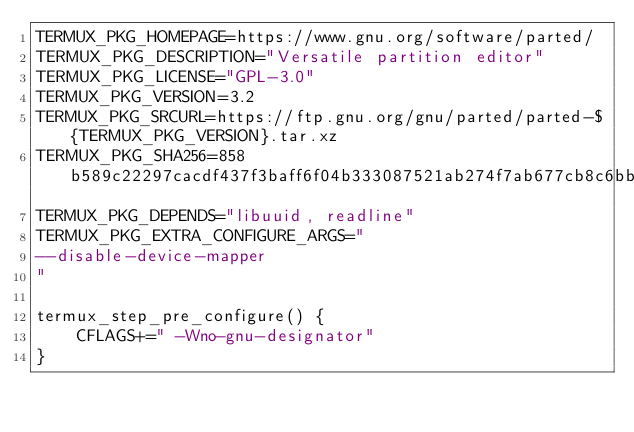<code> <loc_0><loc_0><loc_500><loc_500><_Bash_>TERMUX_PKG_HOMEPAGE=https://www.gnu.org/software/parted/
TERMUX_PKG_DESCRIPTION="Versatile partition editor"
TERMUX_PKG_LICENSE="GPL-3.0"
TERMUX_PKG_VERSION=3.2
TERMUX_PKG_SRCURL=https://ftp.gnu.org/gnu/parted/parted-${TERMUX_PKG_VERSION}.tar.xz
TERMUX_PKG_SHA256=858b589c22297cacdf437f3baff6f04b333087521ab274f7ab677cb8c6bb78e4
TERMUX_PKG_DEPENDS="libuuid, readline"
TERMUX_PKG_EXTRA_CONFIGURE_ARGS="
--disable-device-mapper
"

termux_step_pre_configure() {
    CFLAGS+=" -Wno-gnu-designator"
}
</code> 